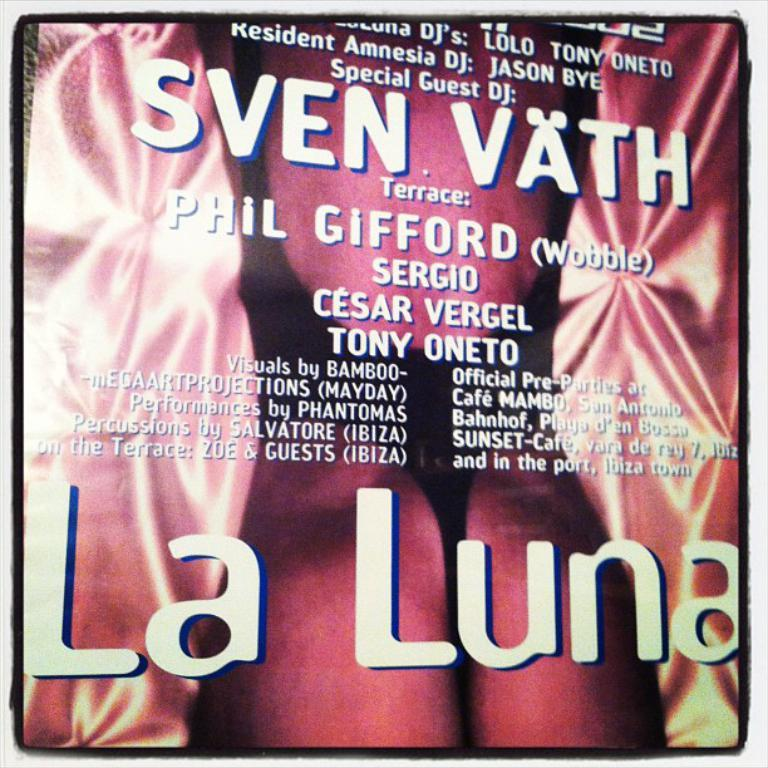<image>
Render a clear and concise summary of the photo. A poster for La Luna and special guest DJs including Phil Gifford. 